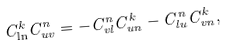<formula> <loc_0><loc_0><loc_500><loc_500>C _ { \ln } ^ { k } C _ { u v } ^ { n } = - C _ { v l } ^ { n } C _ { u n } ^ { k } - C _ { l u } ^ { n } C _ { v n } ^ { k } ,</formula> 